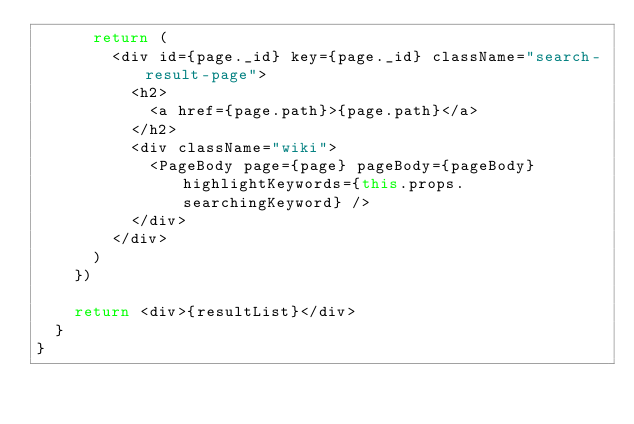<code> <loc_0><loc_0><loc_500><loc_500><_TypeScript_>      return (
        <div id={page._id} key={page._id} className="search-result-page">
          <h2>
            <a href={page.path}>{page.path}</a>
          </h2>
          <div className="wiki">
            <PageBody page={page} pageBody={pageBody} highlightKeywords={this.props.searchingKeyword} />
          </div>
        </div>
      )
    })

    return <div>{resultList}</div>
  }
}
</code> 